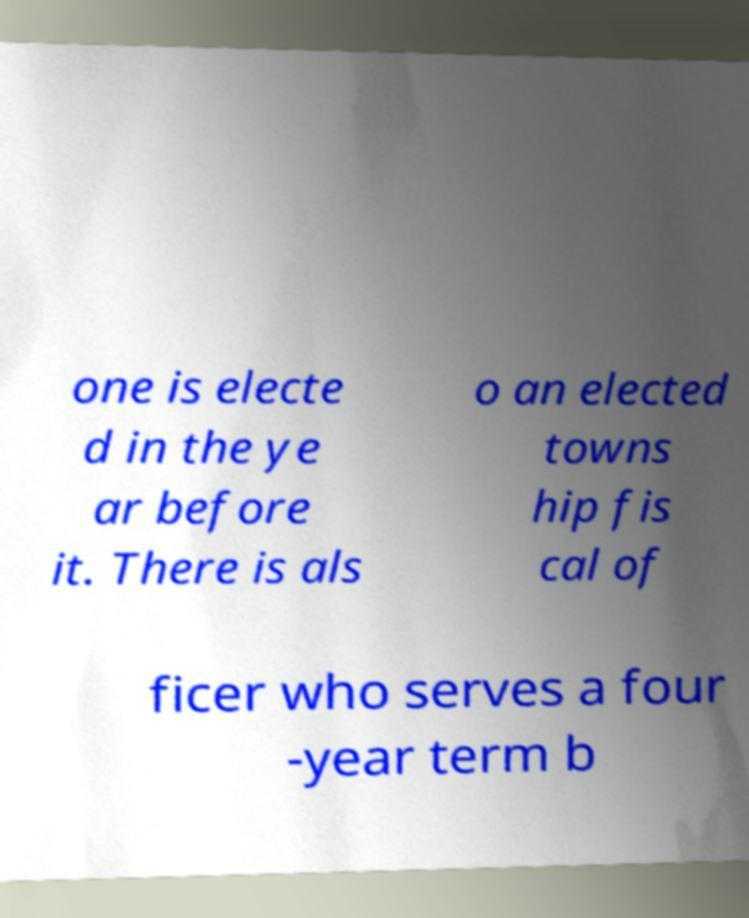Please identify and transcribe the text found in this image. one is electe d in the ye ar before it. There is als o an elected towns hip fis cal of ficer who serves a four -year term b 